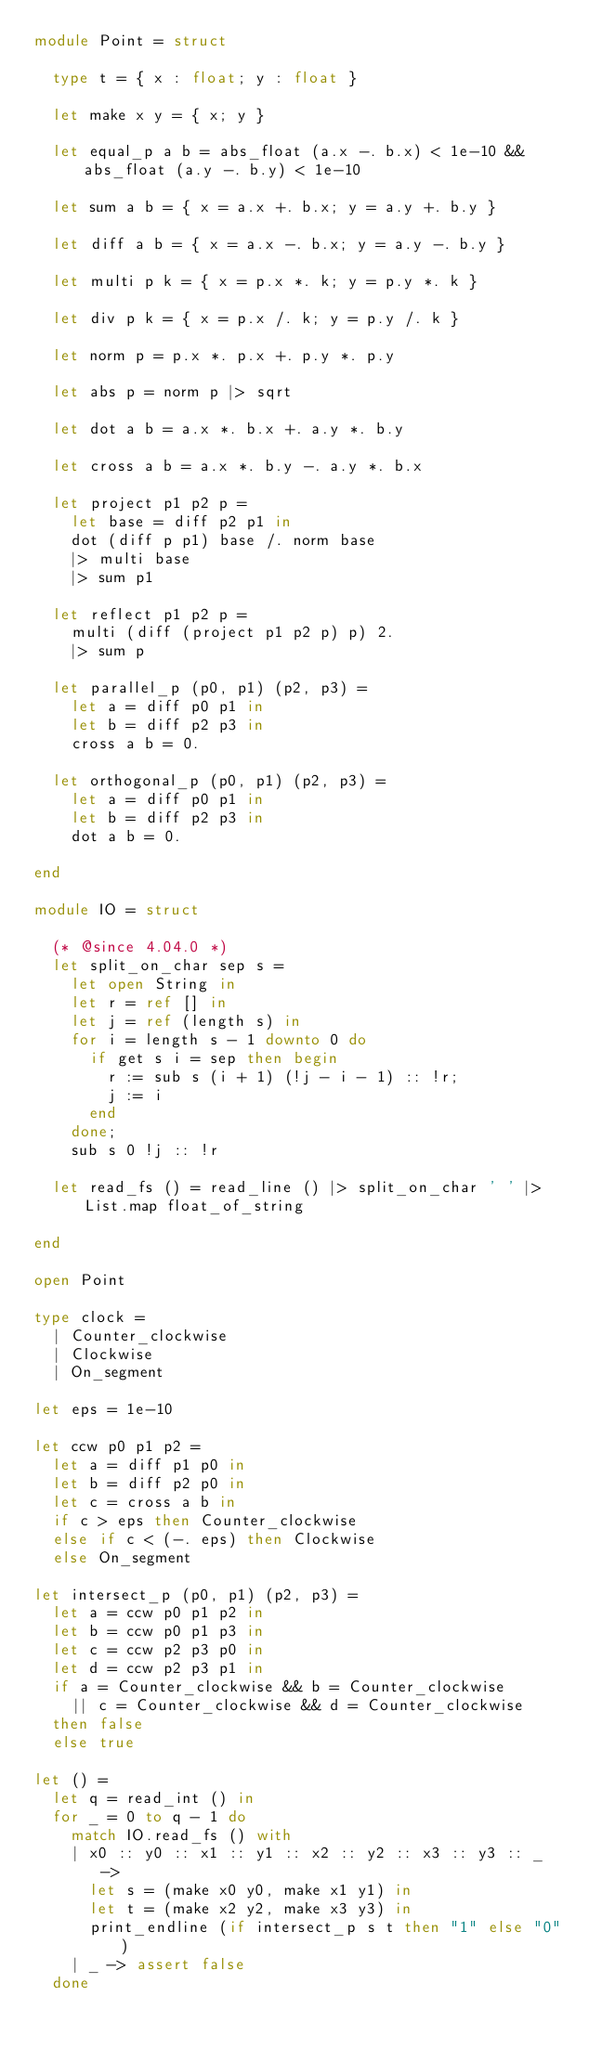<code> <loc_0><loc_0><loc_500><loc_500><_OCaml_>module Point = struct

  type t = { x : float; y : float }

  let make x y = { x; y }

  let equal_p a b = abs_float (a.x -. b.x) < 1e-10 && abs_float (a.y -. b.y) < 1e-10

  let sum a b = { x = a.x +. b.x; y = a.y +. b.y }

  let diff a b = { x = a.x -. b.x; y = a.y -. b.y }

  let multi p k = { x = p.x *. k; y = p.y *. k }

  let div p k = { x = p.x /. k; y = p.y /. k }

  let norm p = p.x *. p.x +. p.y *. p.y

  let abs p = norm p |> sqrt

  let dot a b = a.x *. b.x +. a.y *. b.y

  let cross a b = a.x *. b.y -. a.y *. b.x

  let project p1 p2 p =
    let base = diff p2 p1 in
    dot (diff p p1) base /. norm base
    |> multi base
    |> sum p1

  let reflect p1 p2 p =
    multi (diff (project p1 p2 p) p) 2.
    |> sum p

  let parallel_p (p0, p1) (p2, p3) =
    let a = diff p0 p1 in
    let b = diff p2 p3 in
    cross a b = 0.

  let orthogonal_p (p0, p1) (p2, p3) =
    let a = diff p0 p1 in
    let b = diff p2 p3 in
    dot a b = 0.

end

module IO = struct

  (* @since 4.04.0 *)
  let split_on_char sep s =
    let open String in
    let r = ref [] in
    let j = ref (length s) in
    for i = length s - 1 downto 0 do
      if get s i = sep then begin
        r := sub s (i + 1) (!j - i - 1) :: !r;
        j := i
      end
    done;
    sub s 0 !j :: !r

  let read_fs () = read_line () |> split_on_char ' ' |> List.map float_of_string

end

open Point

type clock =
  | Counter_clockwise
  | Clockwise
  | On_segment

let eps = 1e-10

let ccw p0 p1 p2 =
  let a = diff p1 p0 in
  let b = diff p2 p0 in
  let c = cross a b in
  if c > eps then Counter_clockwise
  else if c < (-. eps) then Clockwise
  else On_segment

let intersect_p (p0, p1) (p2, p3) =
  let a = ccw p0 p1 p2 in
  let b = ccw p0 p1 p3 in
  let c = ccw p2 p3 p0 in
  let d = ccw p2 p3 p1 in
  if a = Counter_clockwise && b = Counter_clockwise
    || c = Counter_clockwise && d = Counter_clockwise
  then false
  else true

let () =
  let q = read_int () in
  for _ = 0 to q - 1 do
    match IO.read_fs () with
    | x0 :: y0 :: x1 :: y1 :: x2 :: y2 :: x3 :: y3 :: _ ->
      let s = (make x0 y0, make x1 y1) in
      let t = (make x2 y2, make x3 y3) in
      print_endline (if intersect_p s t then "1" else "0")
    | _ -> assert false
  done</code> 